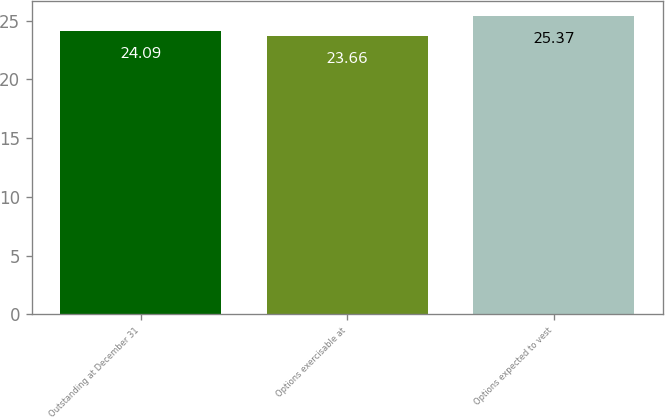<chart> <loc_0><loc_0><loc_500><loc_500><bar_chart><fcel>Outstanding at December 31<fcel>Options exercisable at<fcel>Options expected to vest<nl><fcel>24.09<fcel>23.66<fcel>25.37<nl></chart> 